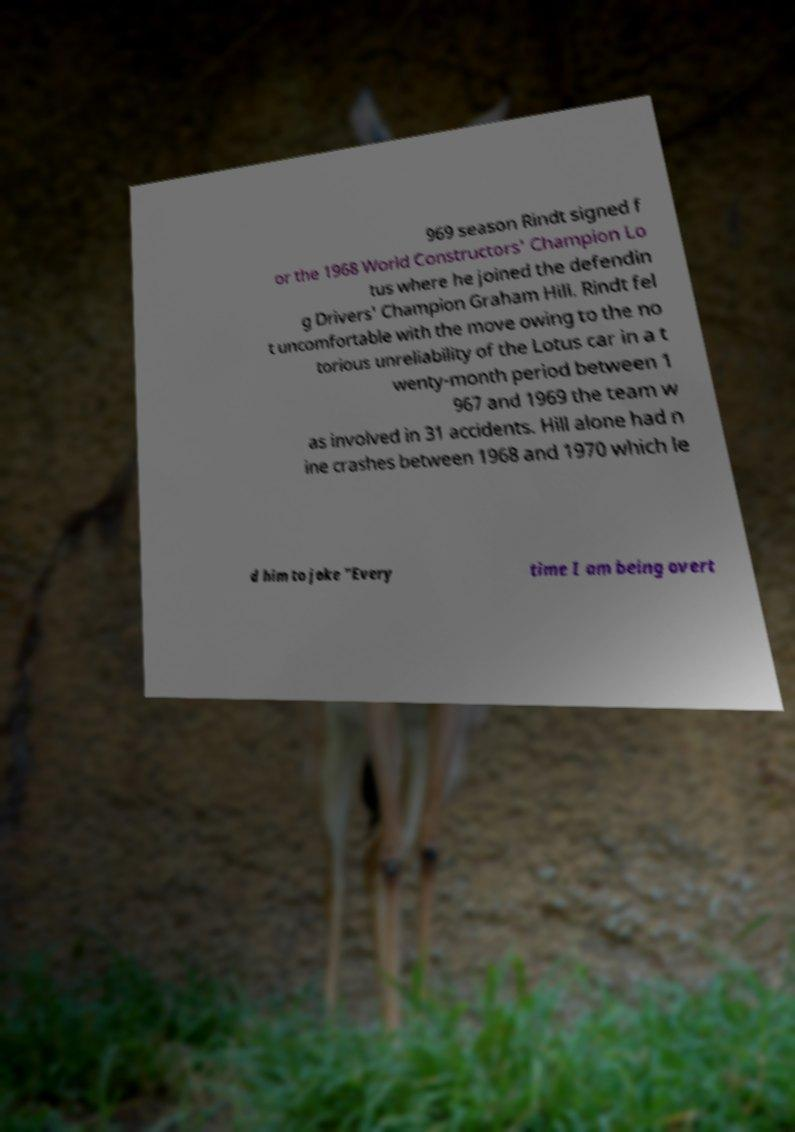There's text embedded in this image that I need extracted. Can you transcribe it verbatim? 969 season Rindt signed f or the 1968 World Constructors' Champion Lo tus where he joined the defendin g Drivers' Champion Graham Hill. Rindt fel t uncomfortable with the move owing to the no torious unreliability of the Lotus car in a t wenty-month period between 1 967 and 1969 the team w as involved in 31 accidents. Hill alone had n ine crashes between 1968 and 1970 which le d him to joke "Every time I am being overt 